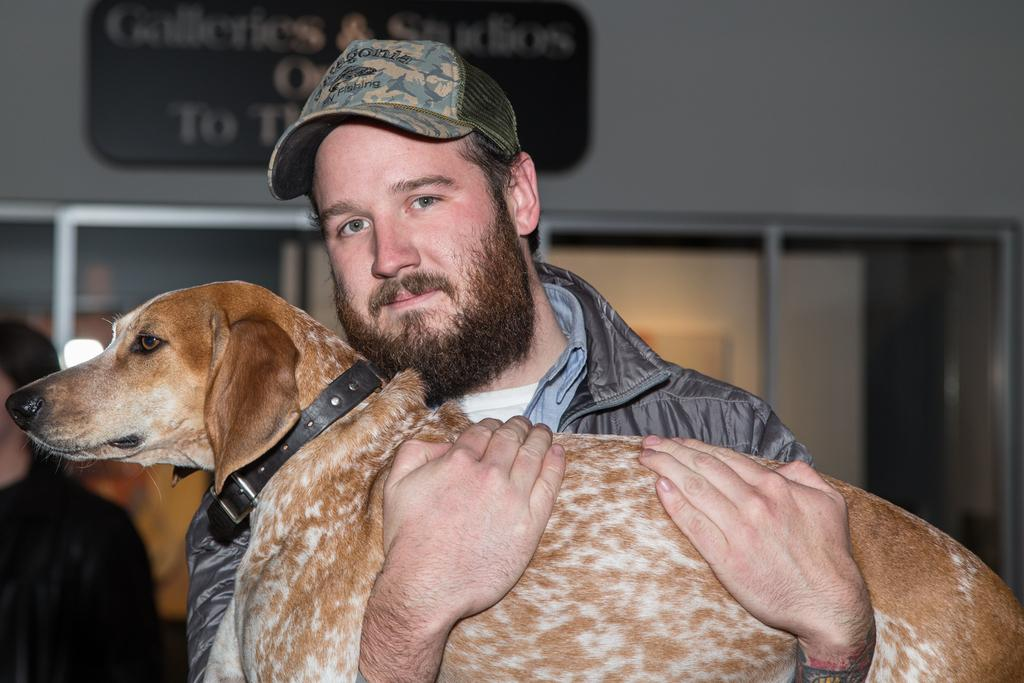What type of clothing is the man wearing on his upper body in the image? The man is wearing a jacket in the image. What type of headwear is the man wearing in the image? The man is wearing a cap in the image. What is the man holding in the image? The man is holding a dog in the image. Can you describe the person standing far away in the image? There is a person standing far away in the image, but no specific details about their appearance or clothing can be discerned. What is on the wall in the image? There is a board on a wall in the image. How many wrens are perched on the houses in the image? There are no wrens or houses present in the image. 